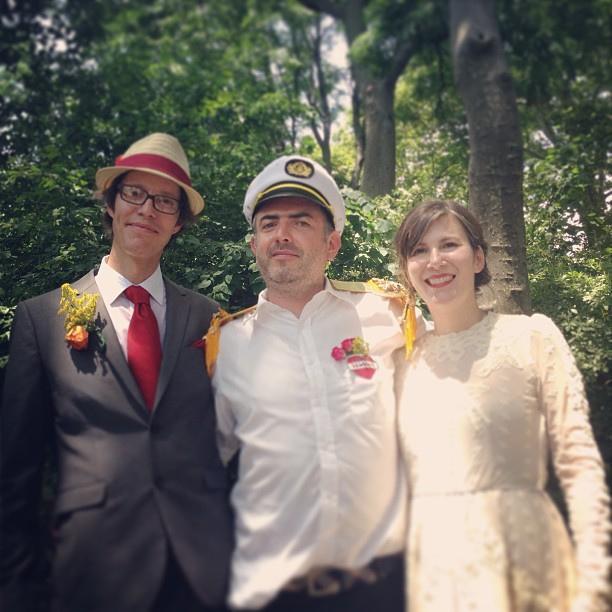What type of hat does the man in white have on?
Indicate the correct response and explain using: 'Answer: answer
Rationale: rationale.'
Options: Captains, skating, athletic, fisherman. Answer: captains.
Rationale: The hat has the classic captains symbol and the white and black design that is seen on many ships. 